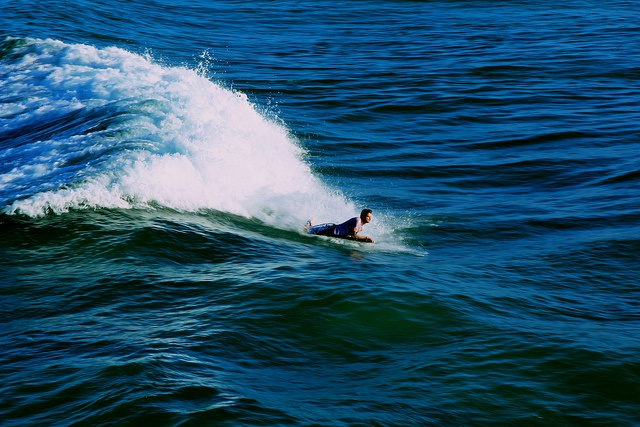Describe the objects in this image and their specific colors. I can see people in blue, black, navy, darkgray, and gray tones and surfboard in blue, black, maroon, and darkgreen tones in this image. 